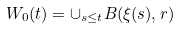Convert formula to latex. <formula><loc_0><loc_0><loc_500><loc_500>W _ { 0 } ( t ) = \cup _ { s \leq t } B ( \xi ( s ) , r )</formula> 